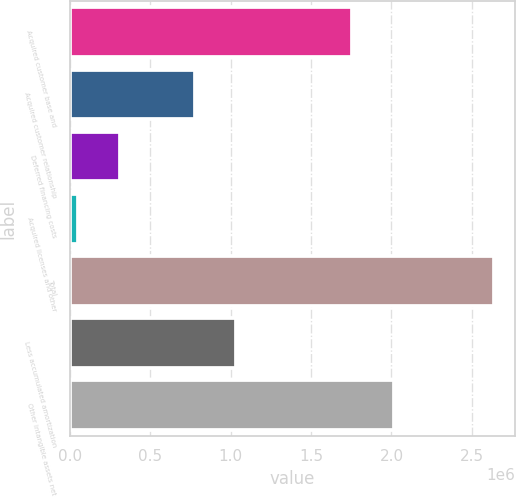Convert chart to OTSL. <chart><loc_0><loc_0><loc_500><loc_500><bar_chart><fcel>Acquired customer base and<fcel>Acquired customer relationship<fcel>Deferred financing costs<fcel>Acquired licenses and other<fcel>Total<fcel>Less accumulated amortization<fcel>Other intangible assets net<nl><fcel>1.7552e+06<fcel>775000<fcel>310332<fcel>51703<fcel>2.63799e+06<fcel>1.03363e+06<fcel>2.01383e+06<nl></chart> 